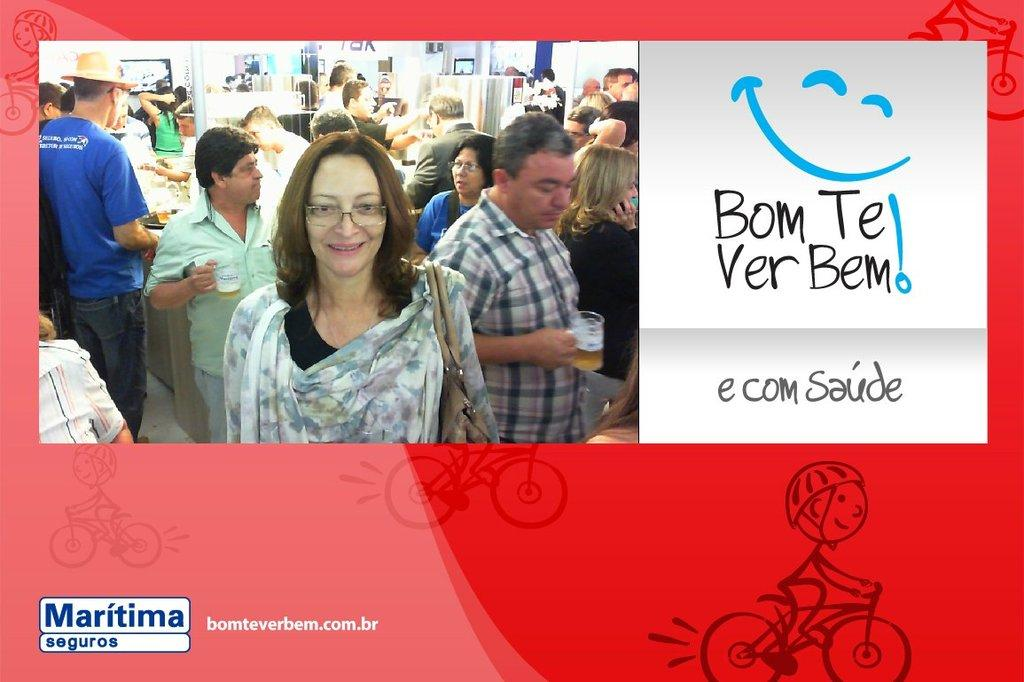What type of visual is depicted in the image? The image appears to be a poster. What information can be found on the poster? There are names on the poster. What is located on the left side of the poster? There is a picture on the left side of the poster. What is the content of the picture on the poster? The picture contains many people. Can you tell me how many zippers are visible on the people in the picture? There are no zippers visible on the people in the picture, as it is a poster with a picture of many people, not a photograph of individuals wearing clothing with zippers. 